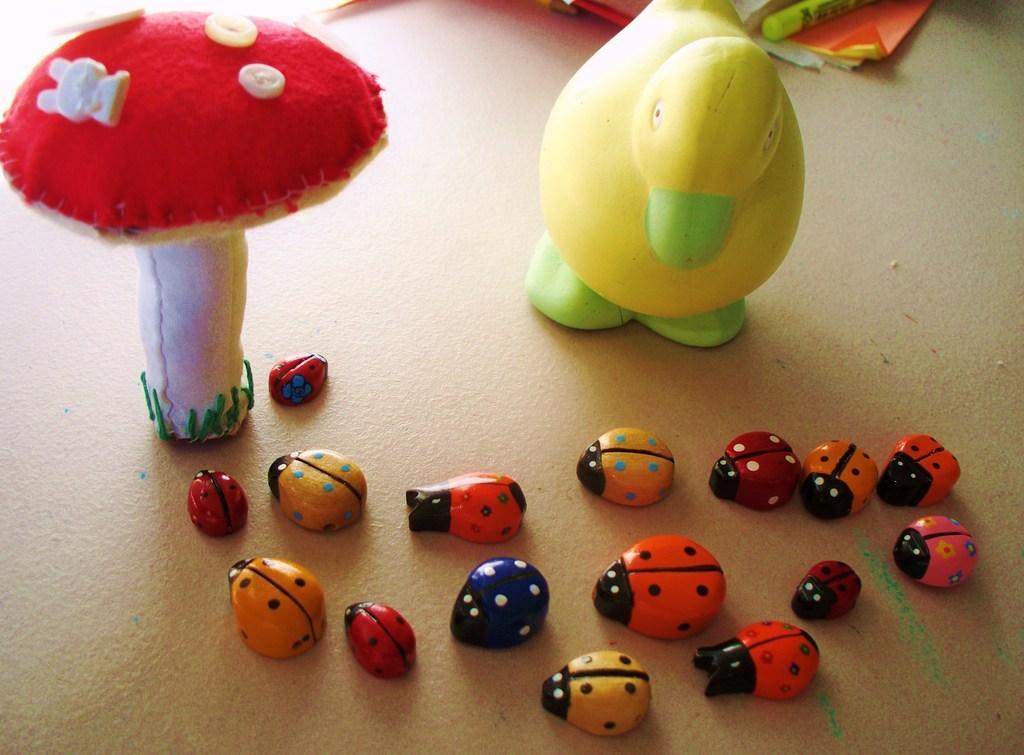Could you give a brief overview of what you see in this image? In this image I can see few kids toys of ladybugs, duck and a mushroom. At the top of the image there are few papers placed on the floor. 